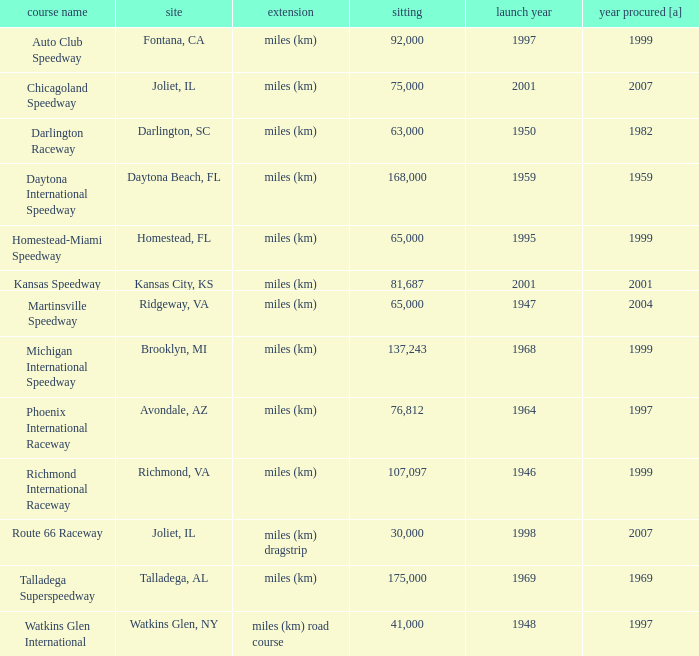What is the year opened for Chicagoland Speedway with a seating smaller than 75,000? None. 